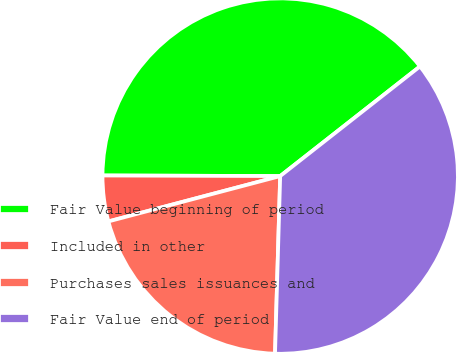Convert chart to OTSL. <chart><loc_0><loc_0><loc_500><loc_500><pie_chart><fcel>Fair Value beginning of period<fcel>Included in other<fcel>Purchases sales issuances and<fcel>Fair Value end of period<nl><fcel>39.36%<fcel>4.16%<fcel>20.43%<fcel>36.05%<nl></chart> 